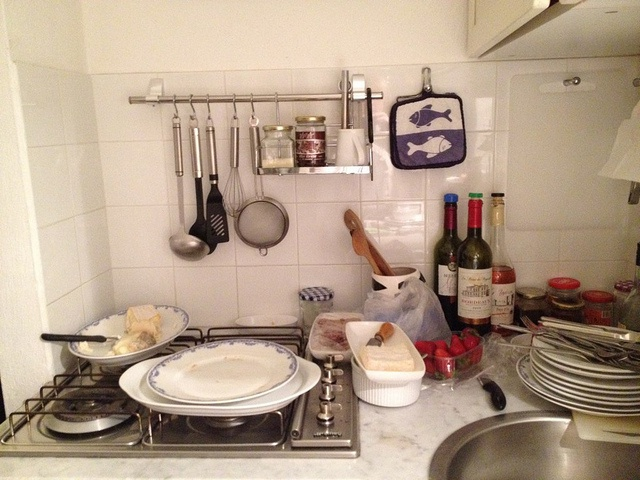Describe the objects in this image and their specific colors. I can see oven in tan, black, and gray tones, bottle in tan, black, gray, and maroon tones, bowl in beige, tan, darkgray, and gray tones, bottle in tan, gray, maroon, and brown tones, and bowl in tan, white, darkgray, and lightgray tones in this image. 